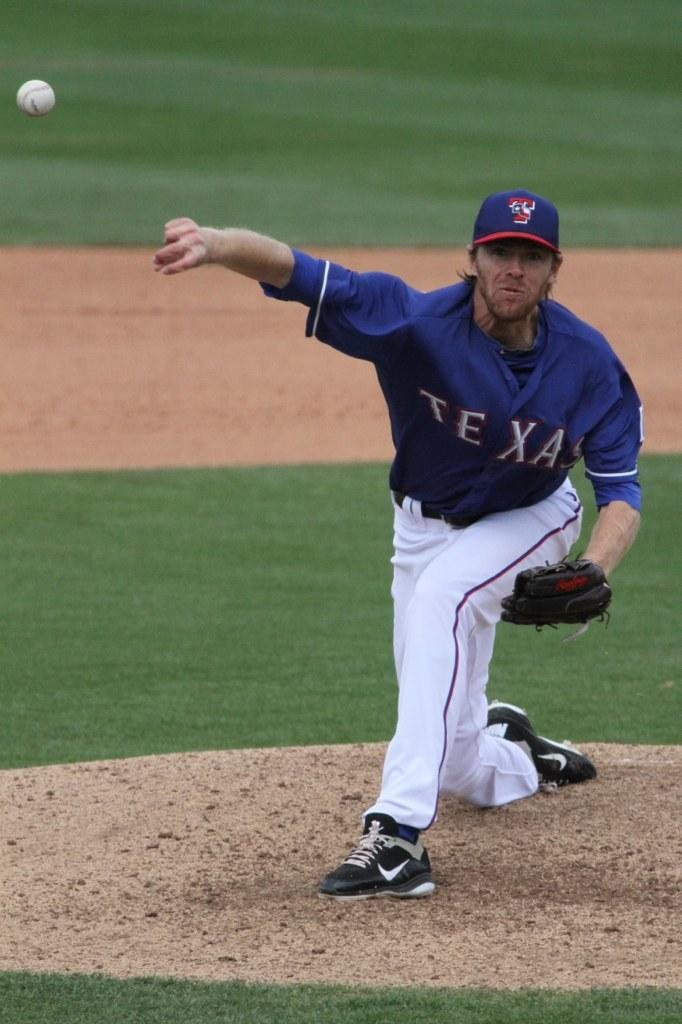<image>
Offer a succinct explanation of the picture presented. A Texas baseball pitcher in a blue jersey and white pants pitching a ball 